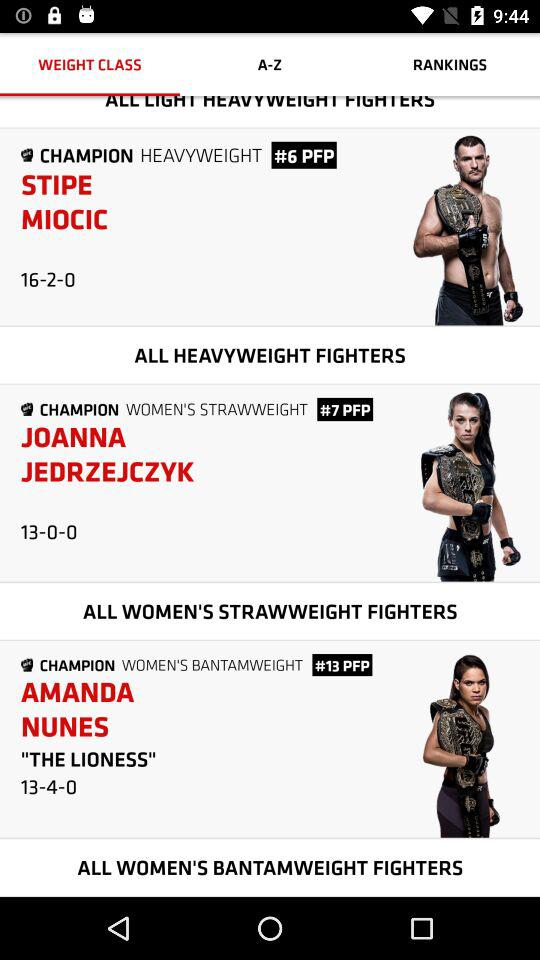What is the name of the heavyweight champion? The name of the heavyweight champion is Stipe Miocic. 